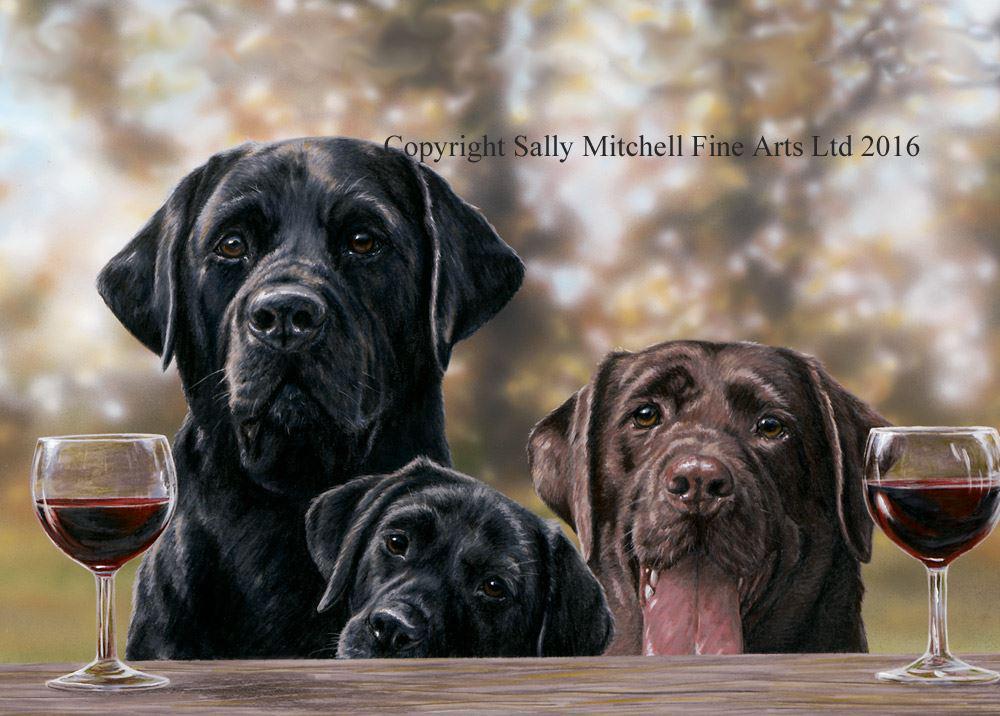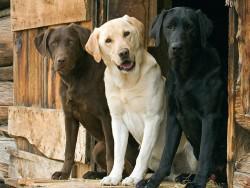The first image is the image on the left, the second image is the image on the right. Evaluate the accuracy of this statement regarding the images: "There are six dogs in total.". Is it true? Answer yes or no. Yes. The first image is the image on the left, the second image is the image on the right. Evaluate the accuracy of this statement regarding the images: "A person's legs are visible behind at least one dog.". Is it true? Answer yes or no. No. 